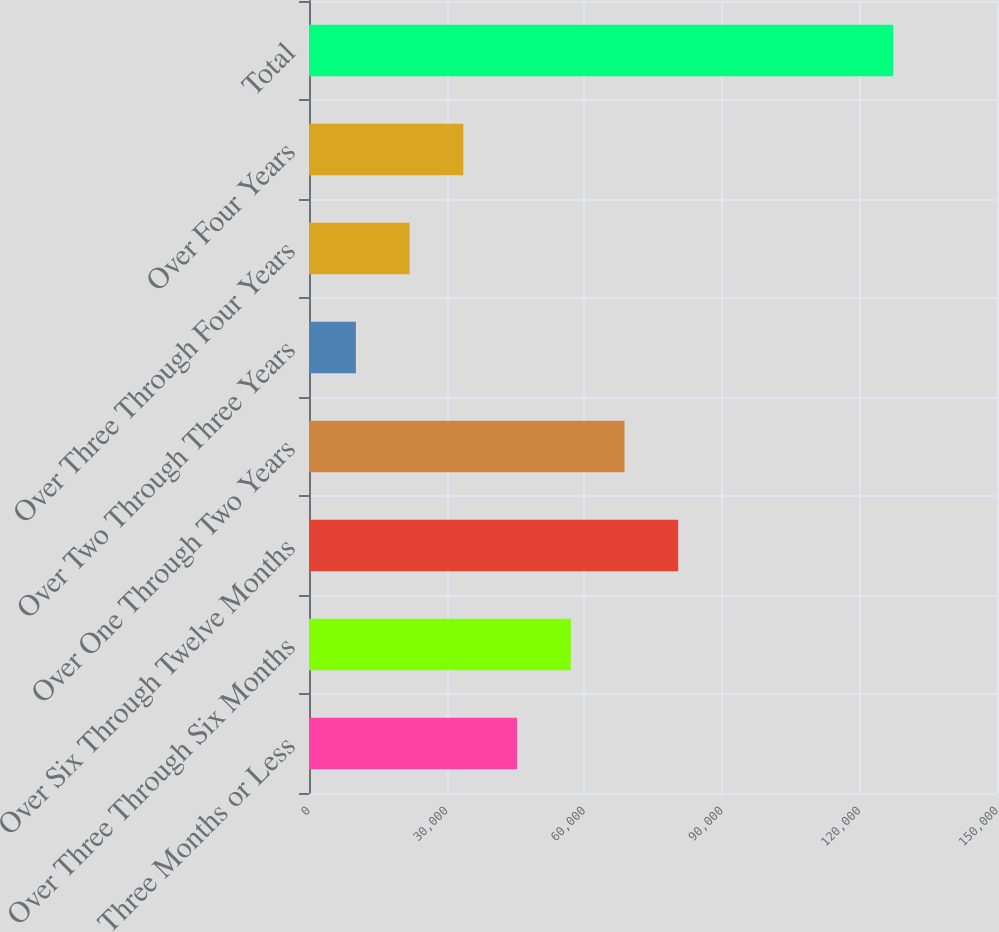Convert chart to OTSL. <chart><loc_0><loc_0><loc_500><loc_500><bar_chart><fcel>Three Months or Less<fcel>Over Three Through Six Months<fcel>Over Six Through Twelve Months<fcel>Over One Through Two Years<fcel>Over Two Through Three Years<fcel>Over Three Through Four Years<fcel>Over Four Years<fcel>Total<nl><fcel>45360.5<fcel>57072<fcel>80495<fcel>68783.5<fcel>10226<fcel>21937.5<fcel>33649<fcel>127341<nl></chart> 